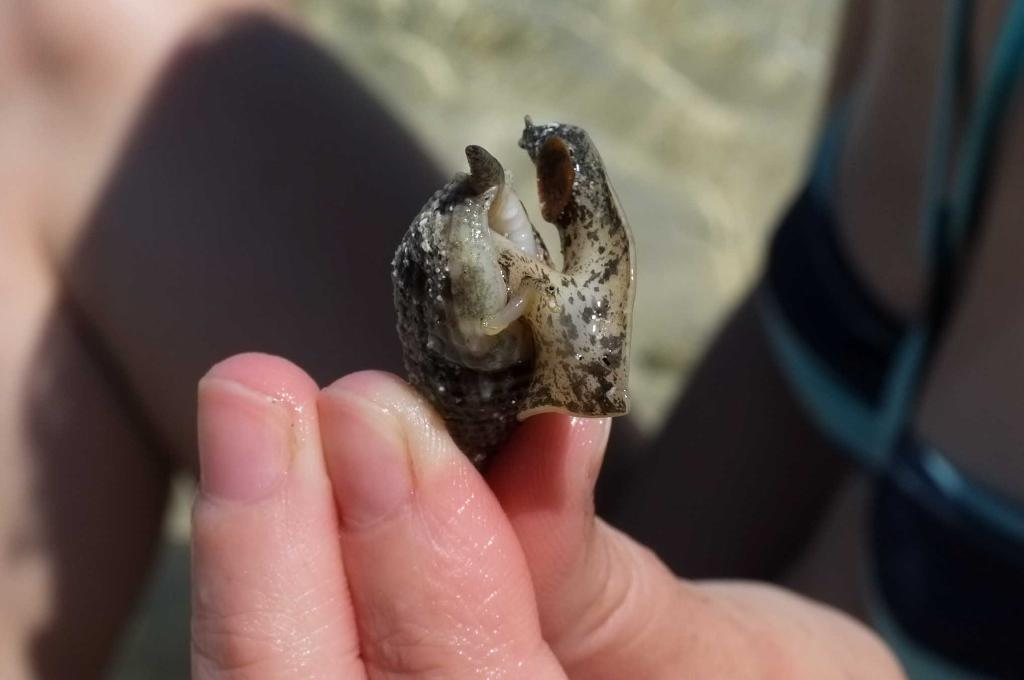What is present in the image? There is a person in the image. What is the person holding? The person is holding a snail. What type of nose does the snail have in the image? There is no nose present on the snail in the image, as snails have tentacles for sensing their environment. 